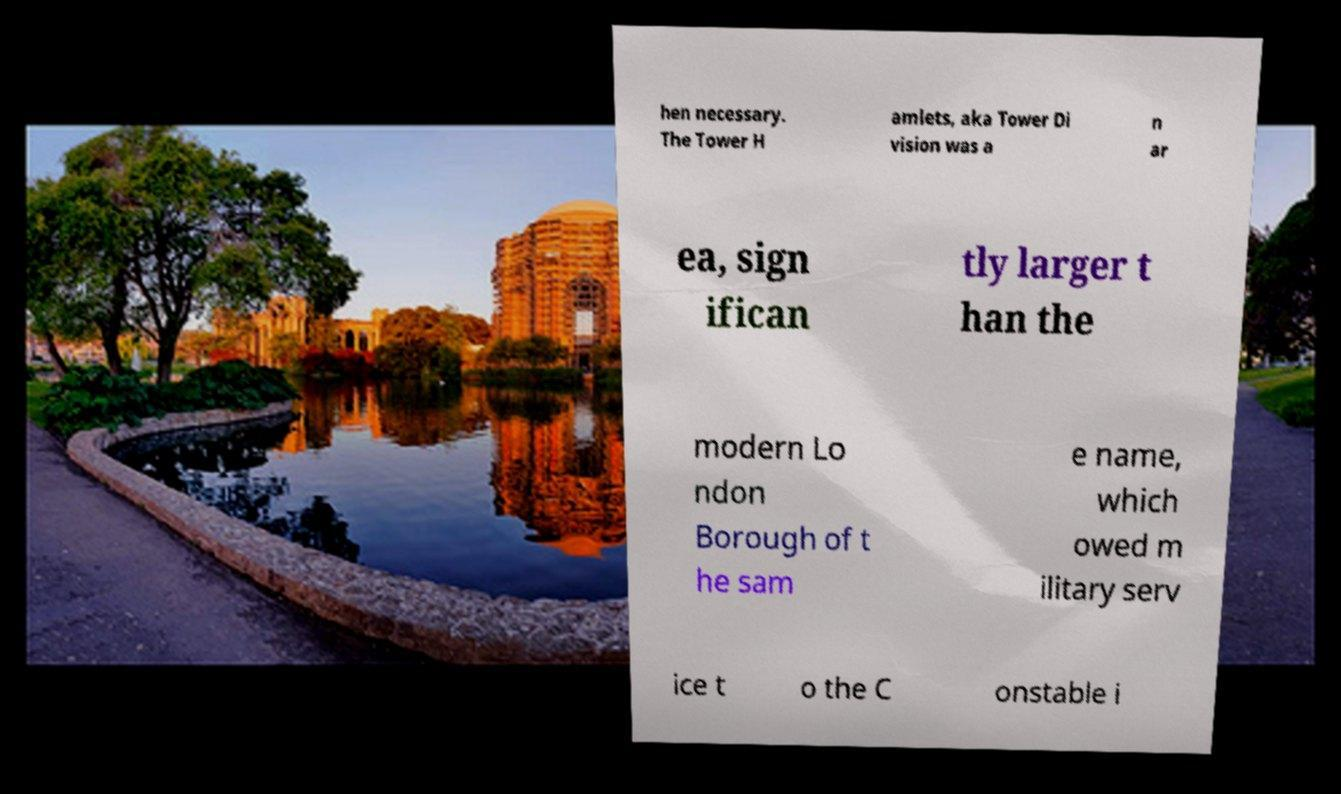I need the written content from this picture converted into text. Can you do that? hen necessary. The Tower H amlets, aka Tower Di vision was a n ar ea, sign ifican tly larger t han the modern Lo ndon Borough of t he sam e name, which owed m ilitary serv ice t o the C onstable i 